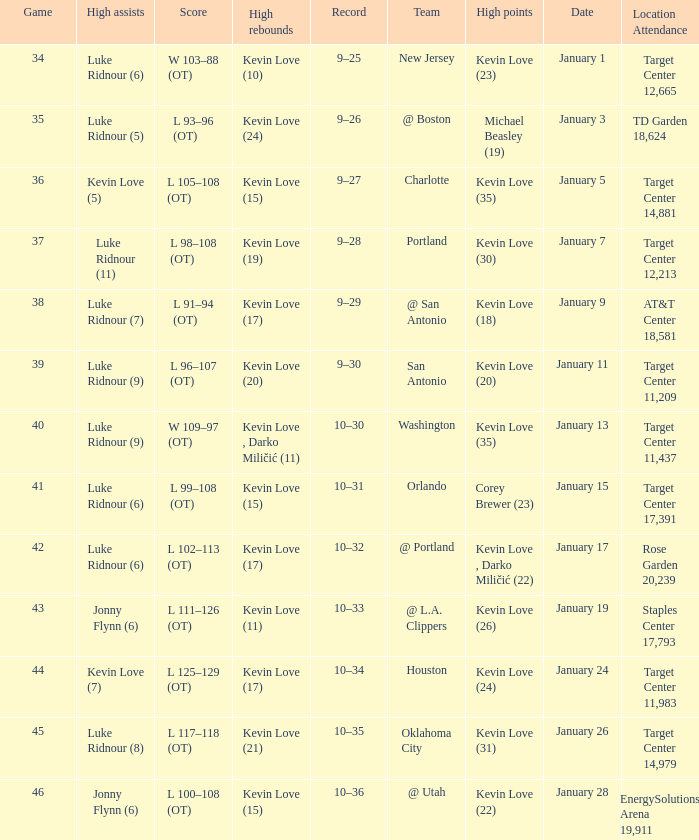Can you parse all the data within this table? {'header': ['Game', 'High assists', 'Score', 'High rebounds', 'Record', 'Team', 'High points', 'Date', 'Location Attendance'], 'rows': [['34', 'Luke Ridnour (6)', 'W 103–88 (OT)', 'Kevin Love (10)', '9–25', 'New Jersey', 'Kevin Love (23)', 'January 1', 'Target Center 12,665'], ['35', 'Luke Ridnour (5)', 'L 93–96 (OT)', 'Kevin Love (24)', '9–26', '@ Boston', 'Michael Beasley (19)', 'January 3', 'TD Garden 18,624'], ['36', 'Kevin Love (5)', 'L 105–108 (OT)', 'Kevin Love (15)', '9–27', 'Charlotte', 'Kevin Love (35)', 'January 5', 'Target Center 14,881'], ['37', 'Luke Ridnour (11)', 'L 98–108 (OT)', 'Kevin Love (19)', '9–28', 'Portland', 'Kevin Love (30)', 'January 7', 'Target Center 12,213'], ['38', 'Luke Ridnour (7)', 'L 91–94 (OT)', 'Kevin Love (17)', '9–29', '@ San Antonio', 'Kevin Love (18)', 'January 9', 'AT&T Center 18,581'], ['39', 'Luke Ridnour (9)', 'L 96–107 (OT)', 'Kevin Love (20)', '9–30', 'San Antonio', 'Kevin Love (20)', 'January 11', 'Target Center 11,209'], ['40', 'Luke Ridnour (9)', 'W 109–97 (OT)', 'Kevin Love , Darko Miličić (11)', '10–30', 'Washington', 'Kevin Love (35)', 'January 13', 'Target Center 11,437'], ['41', 'Luke Ridnour (6)', 'L 99–108 (OT)', 'Kevin Love (15)', '10–31', 'Orlando', 'Corey Brewer (23)', 'January 15', 'Target Center 17,391'], ['42', 'Luke Ridnour (6)', 'L 102–113 (OT)', 'Kevin Love (17)', '10–32', '@ Portland', 'Kevin Love , Darko Miličić (22)', 'January 17', 'Rose Garden 20,239'], ['43', 'Jonny Flynn (6)', 'L 111–126 (OT)', 'Kevin Love (11)', '10–33', '@ L.A. Clippers', 'Kevin Love (26)', 'January 19', 'Staples Center 17,793'], ['44', 'Kevin Love (7)', 'L 125–129 (OT)', 'Kevin Love (17)', '10–34', 'Houston', 'Kevin Love (24)', 'January 24', 'Target Center 11,983'], ['45', 'Luke Ridnour (8)', 'L 117–118 (OT)', 'Kevin Love (21)', '10–35', 'Oklahoma City', 'Kevin Love (31)', 'January 26', 'Target Center 14,979'], ['46', 'Jonny Flynn (6)', 'L 100–108 (OT)', 'Kevin Love (15)', '10–36', '@ Utah', 'Kevin Love (22)', 'January 28', 'EnergySolutions Arena 19,911']]} Who had the high points when the team was charlotte? Kevin Love (35). 